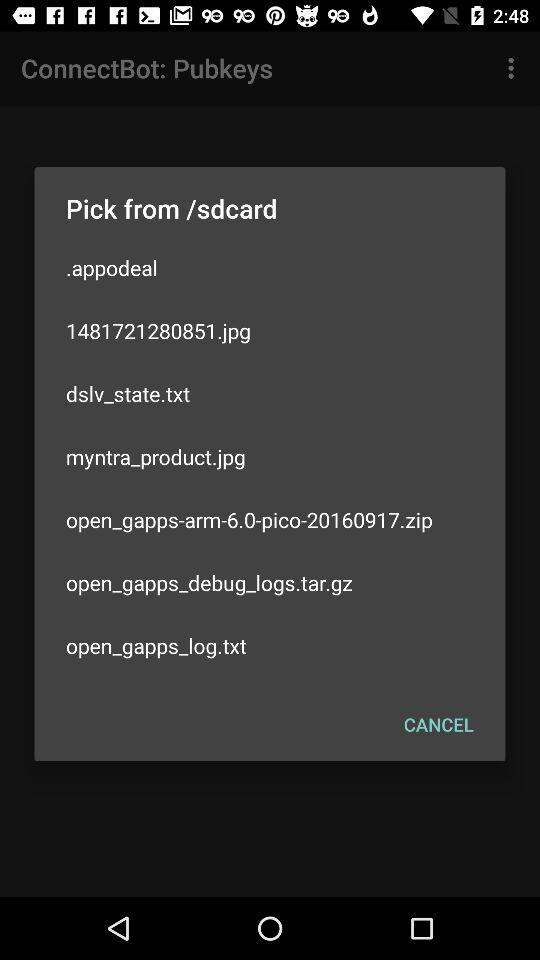What is the name of the image? The names of the images are "1481721280851.jpg" and "myntra_product.jpg". 